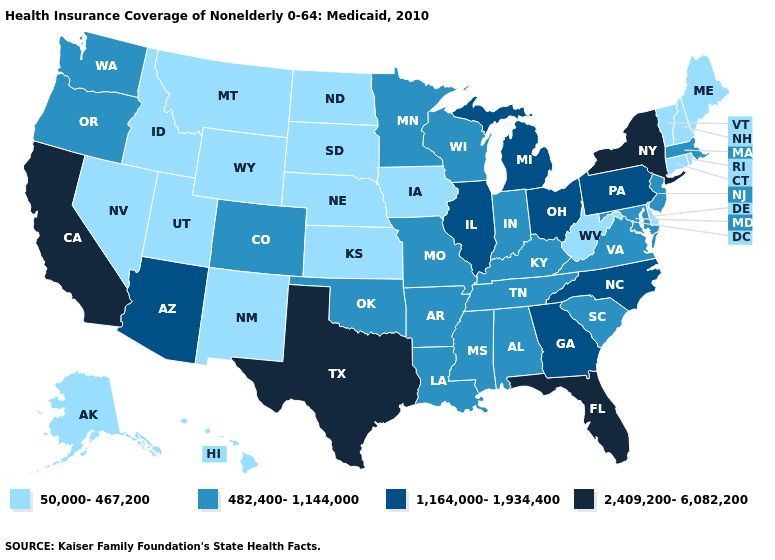What is the value of Indiana?
Give a very brief answer. 482,400-1,144,000. What is the value of Arizona?
Short answer required. 1,164,000-1,934,400. Does New York have the highest value in the USA?
Answer briefly. Yes. How many symbols are there in the legend?
Keep it brief. 4. Among the states that border South Dakota , does Montana have the lowest value?
Short answer required. Yes. Among the states that border Texas , does New Mexico have the highest value?
Write a very short answer. No. What is the lowest value in the West?
Write a very short answer. 50,000-467,200. What is the value of Arizona?
Keep it brief. 1,164,000-1,934,400. What is the value of Pennsylvania?
Write a very short answer. 1,164,000-1,934,400. What is the lowest value in states that border Florida?
Be succinct. 482,400-1,144,000. Name the states that have a value in the range 50,000-467,200?
Quick response, please. Alaska, Connecticut, Delaware, Hawaii, Idaho, Iowa, Kansas, Maine, Montana, Nebraska, Nevada, New Hampshire, New Mexico, North Dakota, Rhode Island, South Dakota, Utah, Vermont, West Virginia, Wyoming. Is the legend a continuous bar?
Be succinct. No. Among the states that border Iowa , which have the highest value?
Quick response, please. Illinois. What is the value of Massachusetts?
Short answer required. 482,400-1,144,000. Does Kansas have the same value as Montana?
Quick response, please. Yes. 